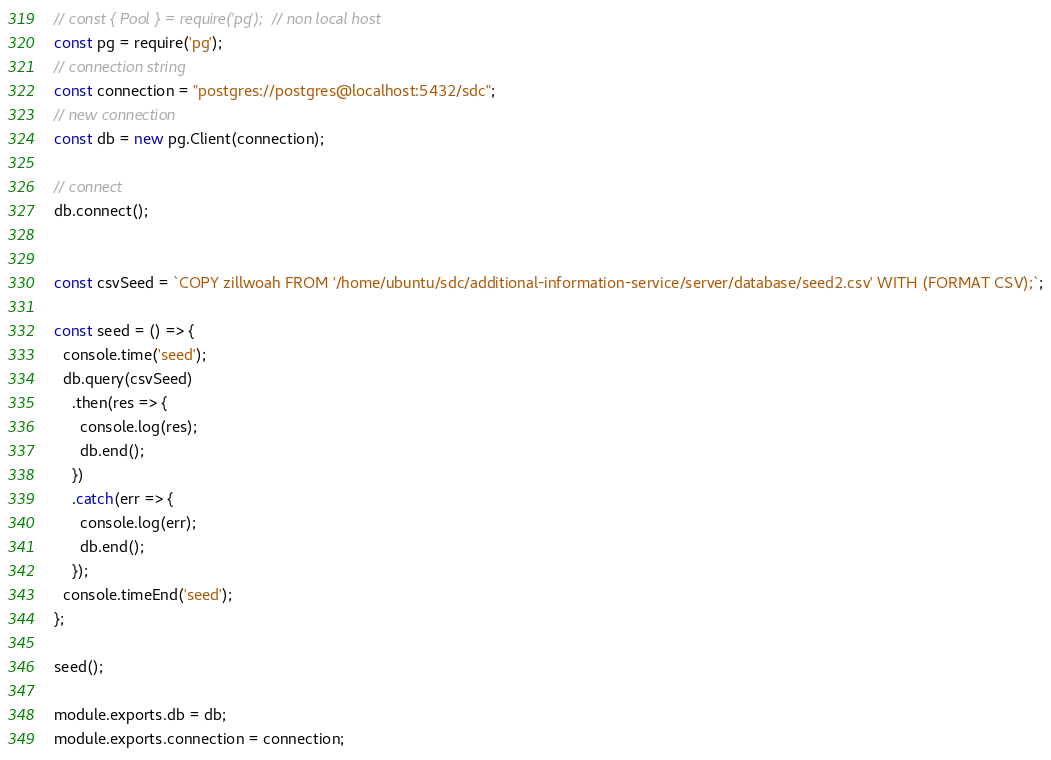Convert code to text. <code><loc_0><loc_0><loc_500><loc_500><_JavaScript_>// const { Pool } = require('pg');  // non local host
const pg = require('pg');
// connection string
const connection = "postgres://postgres@localhost:5432/sdc";
// new connection
const db = new pg.Client(connection);

// connect
db.connect();


const csvSeed = `COPY zillwoah FROM '/home/ubuntu/sdc/additional-information-service/server/database/seed2.csv' WITH (FORMAT CSV);`;

const seed = () => {
  console.time('seed');
  db.query(csvSeed)
    .then(res => {
      console.log(res);
      db.end();
    })
    .catch(err => {
      console.log(err);
      db.end();
    });
  console.timeEnd('seed');
};

seed();

module.exports.db = db;
module.exports.connection = connection;
</code> 